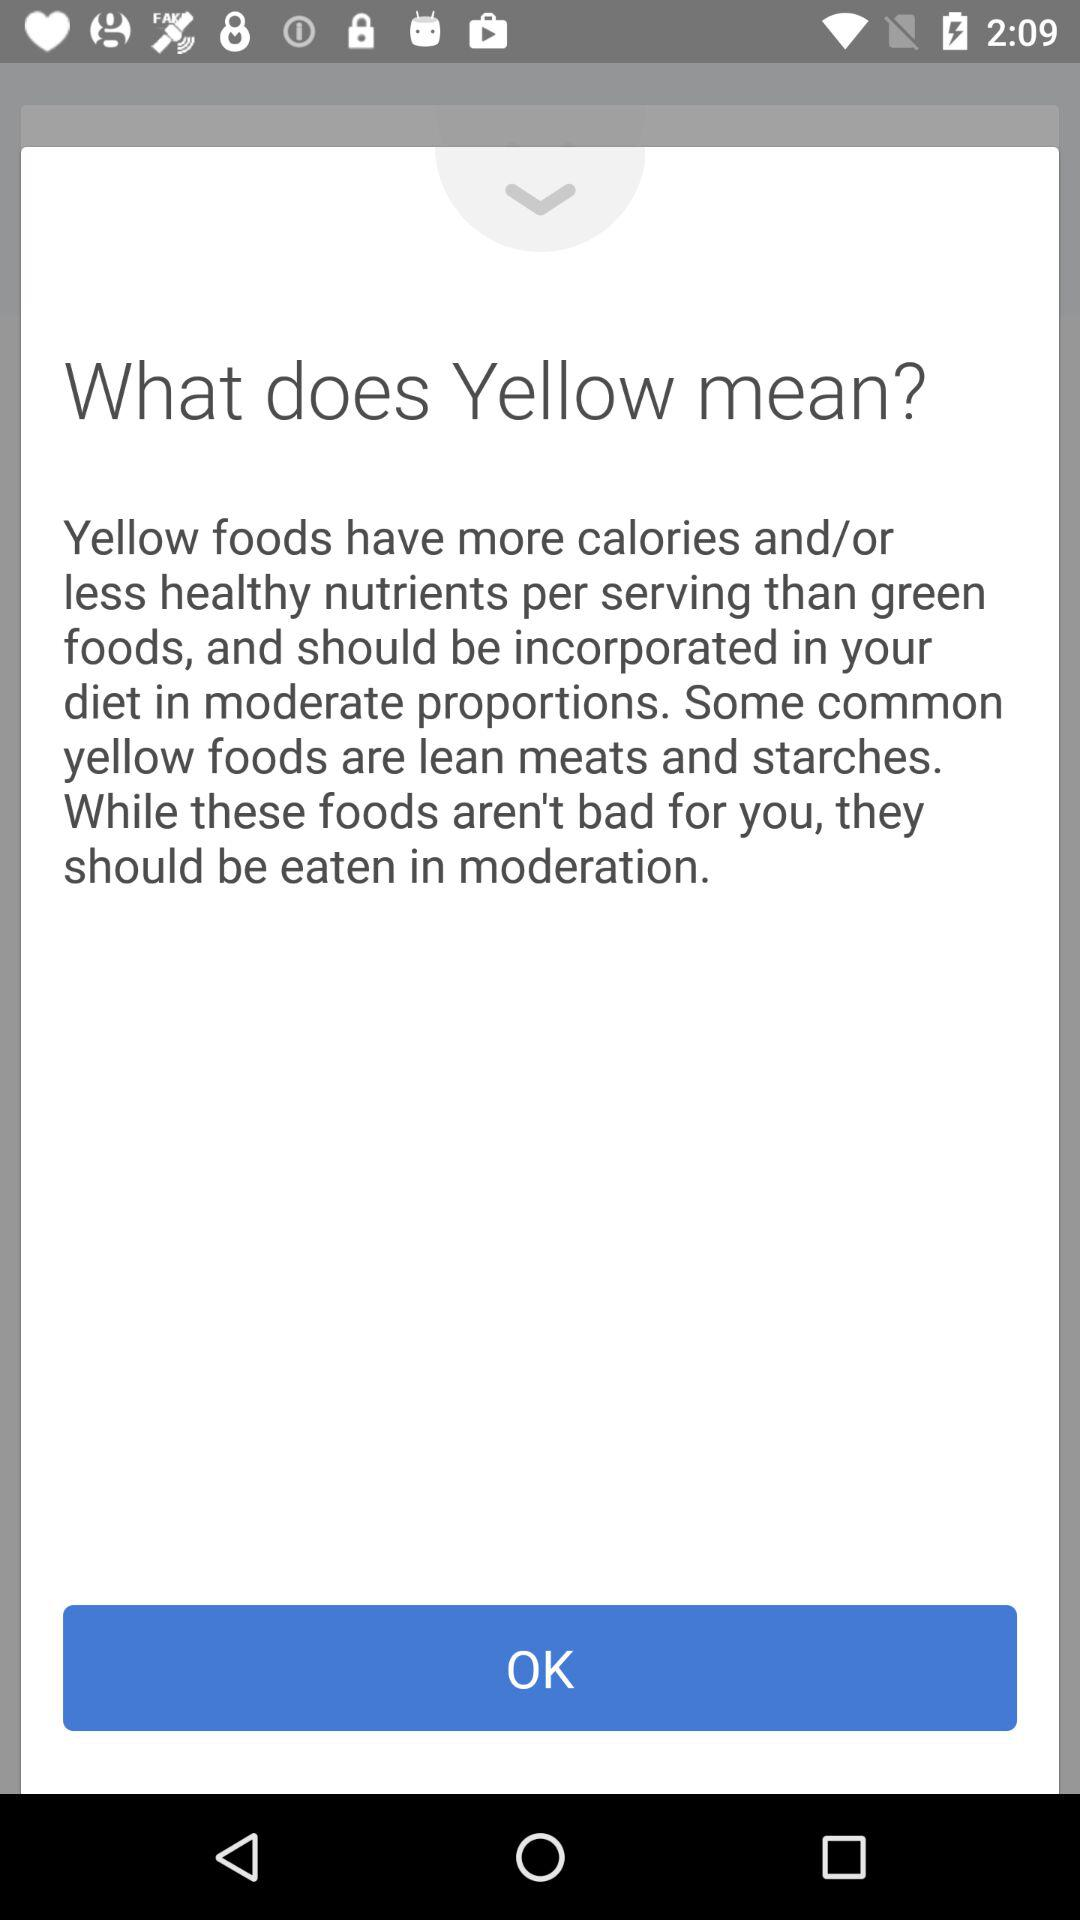What are some common yellow foods? Some common yellow foods are lean meats and starches. 